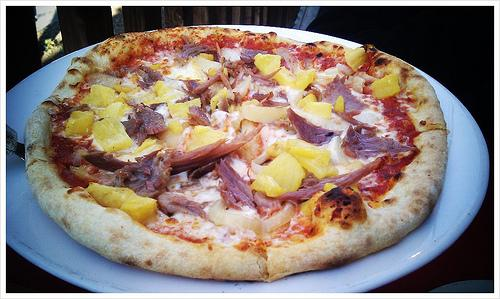What is the color of the plate the pizza is served on in the image? The plate is white. Which is the most noticeable type of meat on the pizza in the image? Shredded ham Describe the appearance of the pizza crust in this image. The crust of the pizza has brown spots and browned cheese, indicating it is well-cooked. Can you count how many slices of pizza are on the plate in the image? There are 8 slices of pizza on the plate. What is the primary sentiment evoked by the image of the pizza? The image evokes feelings of hunger and, possibly, enjoyment. What type of pizza is displayed in the image? It is a Hawaiian style pizza with ham and pineapple. Does the pizza have any red sauce visible in the image? Yes, red tomato sauce is visible on the pizza. What type of fruit is seen on top of the pizza in the image? Pineapple What object lies beneath the pizza in the image, partially hidden by it? There is a handle of a spatula under the pizza. Identify the main type of food in the image. A Hawaiian style pizza sliced into 8 pieces on a white plate. 